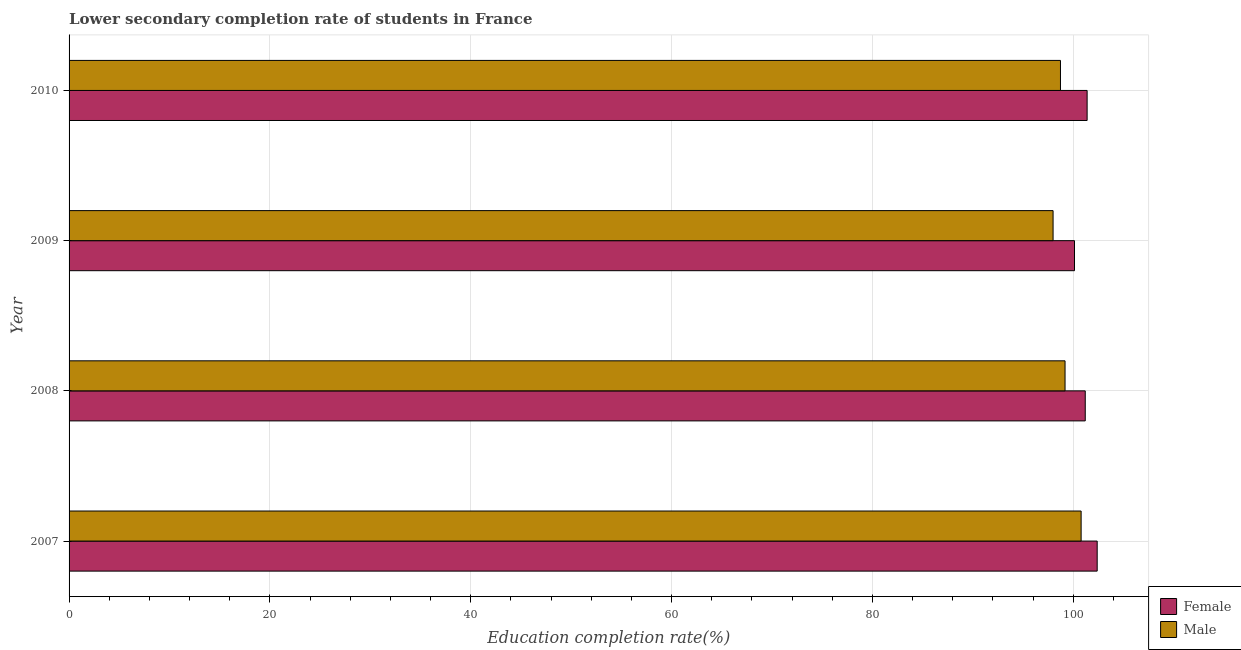How many different coloured bars are there?
Your answer should be compact. 2. Are the number of bars per tick equal to the number of legend labels?
Offer a very short reply. Yes. How many bars are there on the 2nd tick from the top?
Keep it short and to the point. 2. How many bars are there on the 2nd tick from the bottom?
Offer a terse response. 2. What is the label of the 1st group of bars from the top?
Your answer should be compact. 2010. In how many cases, is the number of bars for a given year not equal to the number of legend labels?
Provide a succinct answer. 0. What is the education completion rate of female students in 2010?
Keep it short and to the point. 101.37. Across all years, what is the maximum education completion rate of male students?
Provide a succinct answer. 100.78. Across all years, what is the minimum education completion rate of female students?
Keep it short and to the point. 100.12. In which year was the education completion rate of male students minimum?
Give a very brief answer. 2009. What is the total education completion rate of female students in the graph?
Your answer should be very brief. 405.06. What is the difference between the education completion rate of female students in 2007 and that in 2008?
Your answer should be compact. 1.19. What is the difference between the education completion rate of male students in 2009 and the education completion rate of female students in 2008?
Keep it short and to the point. -3.2. What is the average education completion rate of male students per year?
Keep it short and to the point. 99.17. In the year 2007, what is the difference between the education completion rate of male students and education completion rate of female students?
Keep it short and to the point. -1.6. What is the ratio of the education completion rate of male students in 2008 to that in 2009?
Give a very brief answer. 1.01. Is the education completion rate of female students in 2007 less than that in 2010?
Ensure brevity in your answer.  No. Is the difference between the education completion rate of female students in 2009 and 2010 greater than the difference between the education completion rate of male students in 2009 and 2010?
Your response must be concise. No. What is the difference between the highest and the second highest education completion rate of male students?
Provide a short and direct response. 1.6. What is the difference between the highest and the lowest education completion rate of male students?
Your answer should be compact. 2.79. In how many years, is the education completion rate of male students greater than the average education completion rate of male students taken over all years?
Ensure brevity in your answer.  2. Is the sum of the education completion rate of female students in 2007 and 2010 greater than the maximum education completion rate of male students across all years?
Offer a very short reply. Yes. What does the 2nd bar from the top in 2010 represents?
Ensure brevity in your answer.  Female. How many years are there in the graph?
Keep it short and to the point. 4. What is the difference between two consecutive major ticks on the X-axis?
Ensure brevity in your answer.  20. Are the values on the major ticks of X-axis written in scientific E-notation?
Ensure brevity in your answer.  No. Does the graph contain any zero values?
Offer a terse response. No. How are the legend labels stacked?
Keep it short and to the point. Vertical. What is the title of the graph?
Your response must be concise. Lower secondary completion rate of students in France. Does "Female population" appear as one of the legend labels in the graph?
Provide a short and direct response. No. What is the label or title of the X-axis?
Your answer should be compact. Education completion rate(%). What is the label or title of the Y-axis?
Make the answer very short. Year. What is the Education completion rate(%) in Female in 2007?
Offer a terse response. 102.38. What is the Education completion rate(%) of Male in 2007?
Keep it short and to the point. 100.78. What is the Education completion rate(%) in Female in 2008?
Provide a short and direct response. 101.19. What is the Education completion rate(%) in Male in 2008?
Ensure brevity in your answer.  99.18. What is the Education completion rate(%) in Female in 2009?
Offer a very short reply. 100.12. What is the Education completion rate(%) of Male in 2009?
Offer a terse response. 97.98. What is the Education completion rate(%) in Female in 2010?
Your response must be concise. 101.37. What is the Education completion rate(%) in Male in 2010?
Offer a very short reply. 98.72. Across all years, what is the maximum Education completion rate(%) of Female?
Provide a short and direct response. 102.38. Across all years, what is the maximum Education completion rate(%) of Male?
Your answer should be compact. 100.78. Across all years, what is the minimum Education completion rate(%) of Female?
Make the answer very short. 100.12. Across all years, what is the minimum Education completion rate(%) of Male?
Your answer should be compact. 97.98. What is the total Education completion rate(%) of Female in the graph?
Offer a very short reply. 405.06. What is the total Education completion rate(%) in Male in the graph?
Your answer should be compact. 396.66. What is the difference between the Education completion rate(%) of Female in 2007 and that in 2008?
Make the answer very short. 1.19. What is the difference between the Education completion rate(%) in Male in 2007 and that in 2008?
Your response must be concise. 1.6. What is the difference between the Education completion rate(%) in Female in 2007 and that in 2009?
Offer a terse response. 2.26. What is the difference between the Education completion rate(%) of Male in 2007 and that in 2009?
Give a very brief answer. 2.79. What is the difference between the Education completion rate(%) in Female in 2007 and that in 2010?
Offer a very short reply. 1. What is the difference between the Education completion rate(%) in Male in 2007 and that in 2010?
Provide a short and direct response. 2.06. What is the difference between the Education completion rate(%) in Female in 2008 and that in 2009?
Offer a very short reply. 1.07. What is the difference between the Education completion rate(%) of Male in 2008 and that in 2009?
Make the answer very short. 1.19. What is the difference between the Education completion rate(%) in Female in 2008 and that in 2010?
Your answer should be very brief. -0.19. What is the difference between the Education completion rate(%) in Male in 2008 and that in 2010?
Ensure brevity in your answer.  0.46. What is the difference between the Education completion rate(%) in Female in 2009 and that in 2010?
Your answer should be very brief. -1.26. What is the difference between the Education completion rate(%) of Male in 2009 and that in 2010?
Provide a short and direct response. -0.74. What is the difference between the Education completion rate(%) of Female in 2007 and the Education completion rate(%) of Male in 2008?
Make the answer very short. 3.2. What is the difference between the Education completion rate(%) of Female in 2007 and the Education completion rate(%) of Male in 2009?
Keep it short and to the point. 4.39. What is the difference between the Education completion rate(%) in Female in 2007 and the Education completion rate(%) in Male in 2010?
Keep it short and to the point. 3.65. What is the difference between the Education completion rate(%) in Female in 2008 and the Education completion rate(%) in Male in 2009?
Offer a very short reply. 3.2. What is the difference between the Education completion rate(%) in Female in 2008 and the Education completion rate(%) in Male in 2010?
Your answer should be compact. 2.47. What is the difference between the Education completion rate(%) of Female in 2009 and the Education completion rate(%) of Male in 2010?
Offer a very short reply. 1.4. What is the average Education completion rate(%) of Female per year?
Offer a terse response. 101.26. What is the average Education completion rate(%) of Male per year?
Make the answer very short. 99.16. In the year 2007, what is the difference between the Education completion rate(%) of Female and Education completion rate(%) of Male?
Keep it short and to the point. 1.6. In the year 2008, what is the difference between the Education completion rate(%) in Female and Education completion rate(%) in Male?
Your answer should be very brief. 2.01. In the year 2009, what is the difference between the Education completion rate(%) in Female and Education completion rate(%) in Male?
Provide a succinct answer. 2.13. In the year 2010, what is the difference between the Education completion rate(%) of Female and Education completion rate(%) of Male?
Offer a very short reply. 2.65. What is the ratio of the Education completion rate(%) in Female in 2007 to that in 2008?
Your answer should be compact. 1.01. What is the ratio of the Education completion rate(%) of Male in 2007 to that in 2008?
Ensure brevity in your answer.  1.02. What is the ratio of the Education completion rate(%) in Female in 2007 to that in 2009?
Offer a very short reply. 1.02. What is the ratio of the Education completion rate(%) in Male in 2007 to that in 2009?
Your response must be concise. 1.03. What is the ratio of the Education completion rate(%) in Female in 2007 to that in 2010?
Ensure brevity in your answer.  1.01. What is the ratio of the Education completion rate(%) in Male in 2007 to that in 2010?
Offer a very short reply. 1.02. What is the ratio of the Education completion rate(%) of Female in 2008 to that in 2009?
Provide a short and direct response. 1.01. What is the ratio of the Education completion rate(%) of Male in 2008 to that in 2009?
Offer a terse response. 1.01. What is the ratio of the Education completion rate(%) in Female in 2009 to that in 2010?
Make the answer very short. 0.99. What is the difference between the highest and the second highest Education completion rate(%) of Male?
Your answer should be very brief. 1.6. What is the difference between the highest and the lowest Education completion rate(%) in Female?
Your answer should be very brief. 2.26. What is the difference between the highest and the lowest Education completion rate(%) in Male?
Offer a terse response. 2.79. 